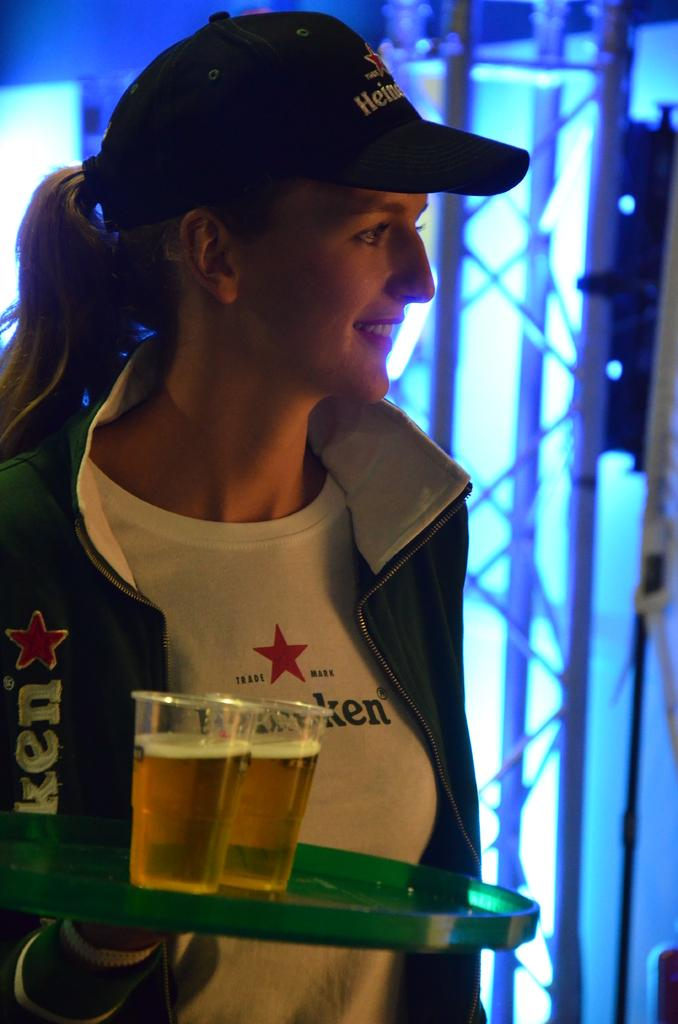Who is the main subject in the image? There is a lady in the image. What is the lady doing in the image? The lady is standing and holding a tray in her hand. What is on the tray that the lady is holding? There are wine glasses on the tray. What can be seen in the background of the image? There are rods and lights in the background of the image. What language is the lady speaking in the image? There is no indication of the language being spoken in the image, as it does not contain any audio. Are there any bushes visible in the image? There is no mention of bushes in the provided facts, and therefore, we cannot determine if they are present in the image. 